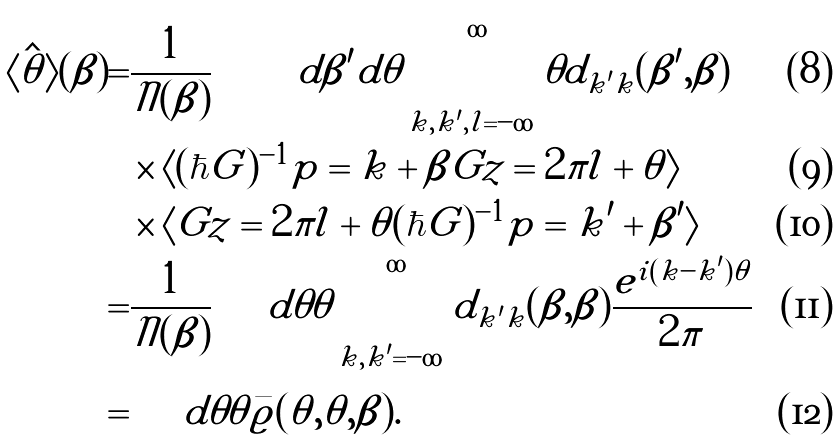Convert formula to latex. <formula><loc_0><loc_0><loc_500><loc_500>\langle \hat { \theta } \rangle ( \beta ) = & \frac { 1 } { \mathcal { N } ( \beta ) } \iint d \beta ^ { \prime } d \theta \sum _ { k , k ^ { \prime } , l = - \infty } ^ { \infty } \theta d _ { k ^ { \prime } k } ( \beta ^ { \prime } , \beta ) \\ & \times \langle ( \hbar { G } ) ^ { - 1 } p = k + \beta | G z = 2 \pi l + \theta \rangle \\ & \times \langle G z = 2 \pi l + \theta | ( \hbar { G } ) ^ { - 1 } p = k ^ { \prime } + \beta ^ { \prime } \rangle \\ = & \frac { 1 } { \mathcal { N } ( \beta ) } \int d \theta \theta \sum _ { k , k ^ { \prime } = - \infty } ^ { \infty } d _ { k ^ { \prime } k } ( \beta , \beta ) \frac { e ^ { i ( k - k ^ { \prime } ) \theta } } { 2 \pi } \\ = & \int d \theta \theta \bar { \varrho } ( \theta , \theta , \beta ) .</formula> 